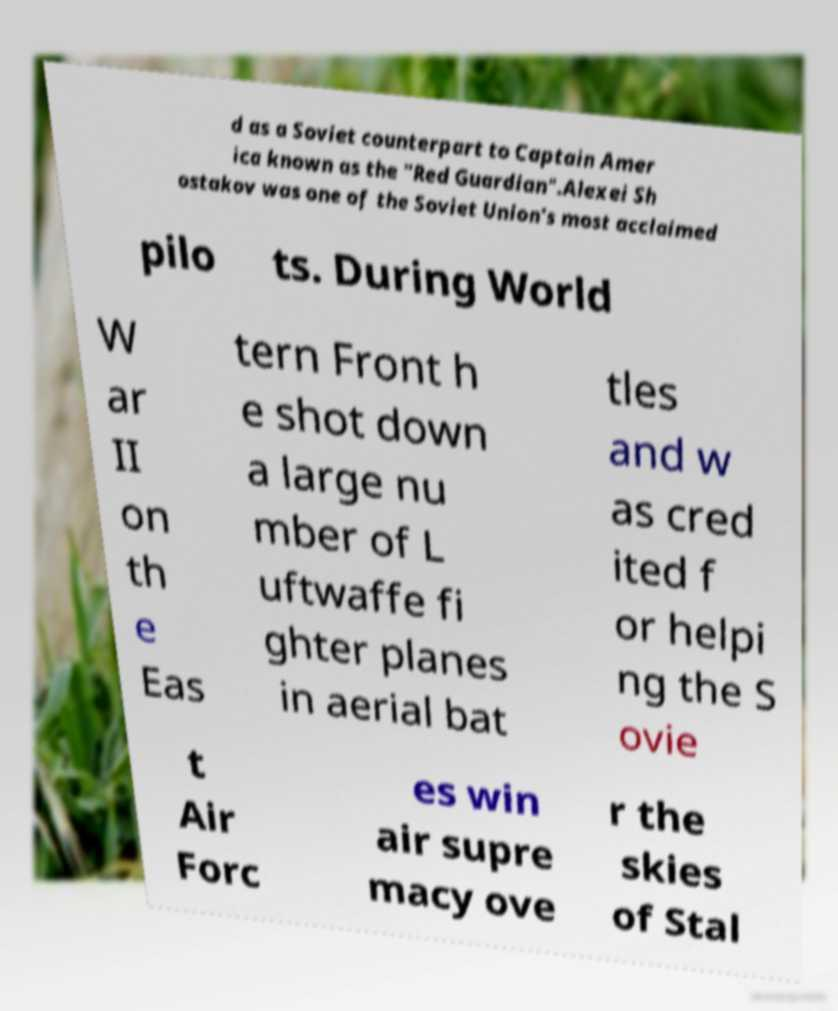Please identify and transcribe the text found in this image. d as a Soviet counterpart to Captain Amer ica known as the "Red Guardian".Alexei Sh ostakov was one of the Soviet Union's most acclaimed pilo ts. During World W ar II on th e Eas tern Front h e shot down a large nu mber of L uftwaffe fi ghter planes in aerial bat tles and w as cred ited f or helpi ng the S ovie t Air Forc es win air supre macy ove r the skies of Stal 